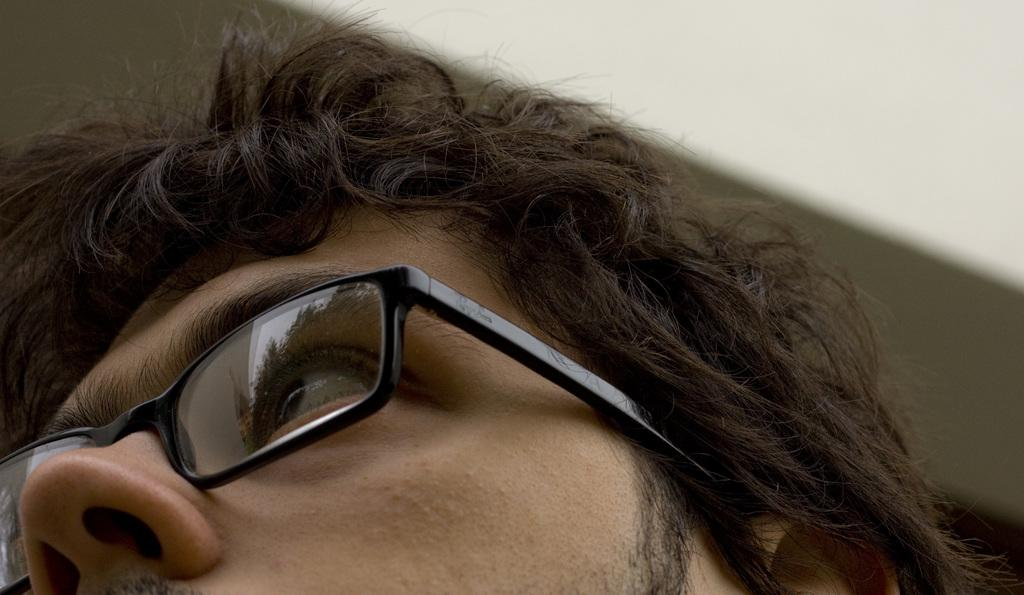What is the main subject of the image? The main subject of the image is a person's face. Can you describe the appearance of the person's face in the image? The person's face is partially obscured or truncated in the image. What accessory is the person wearing in the image? The person is wearing spectacles in the image. How would you describe the background of the image? The background of the image is blurred. How many vases are visible in the image? There are no vases present in the image. What type of rod can be seen supporting the person's face in the image? There is no rod supporting the person's face in the image; it is a photograph or digital representation of a face. 